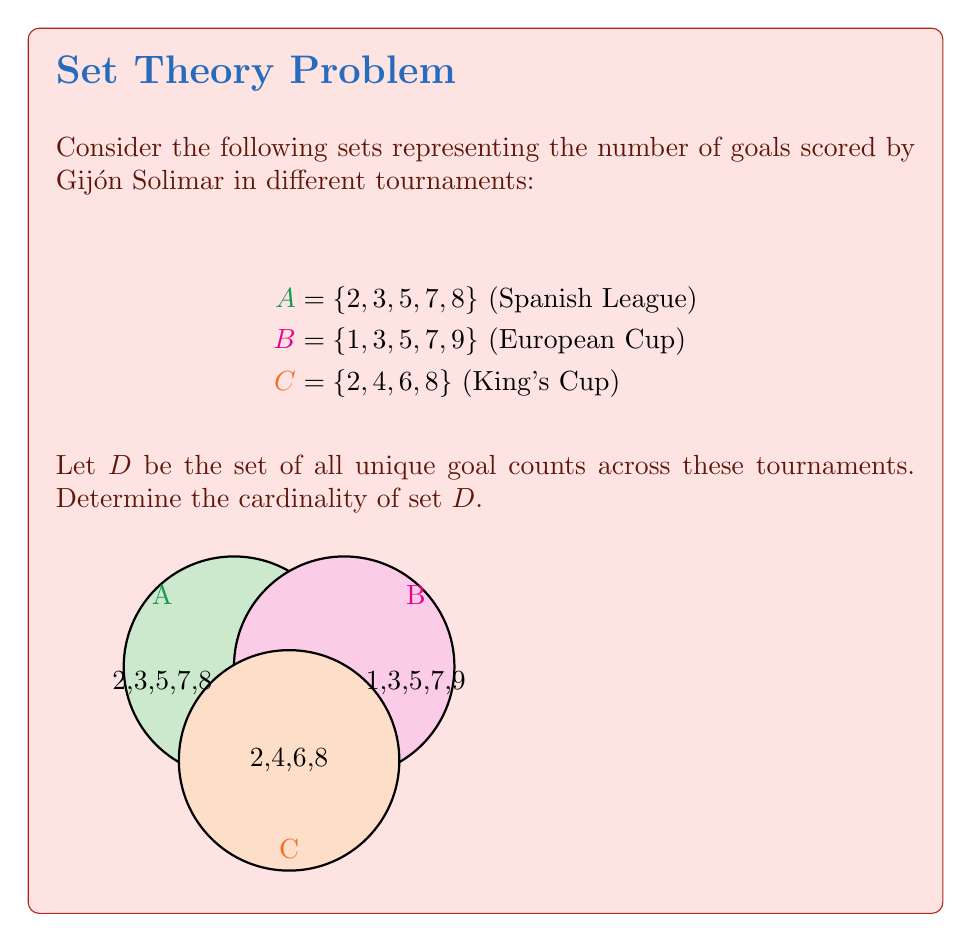Help me with this question. To solve this problem, we need to follow these steps:

1) First, let's identify all the unique elements across sets A, B, and C:
   A = {2, 3, 5, 7, 8}
   B = {1, 3, 5, 7, 9}
   C = {2, 4, 6, 8}

2) Now, let's create set D by combining all unique elements:
   D = {1, 2, 3, 4, 5, 6, 7, 8, 9}

3) To find the cardinality of D, we simply count the number of elements in D.

4) Counting the elements in D:
   $|D| = 9$

Therefore, the cardinality of set D is 9.

This means that Gijón Solimar scored 9 different goal counts across these three tournaments.
Answer: $|D| = 9$ 